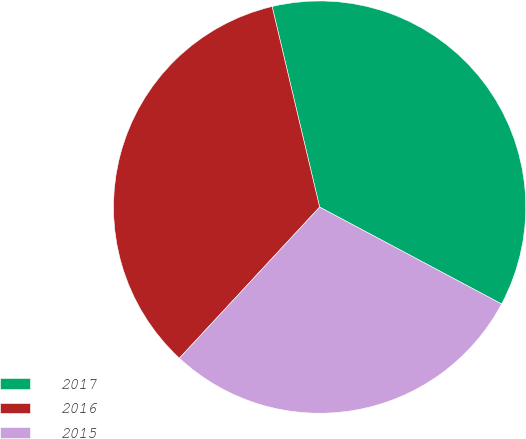Convert chart. <chart><loc_0><loc_0><loc_500><loc_500><pie_chart><fcel>2017<fcel>2016<fcel>2015<nl><fcel>36.49%<fcel>34.39%<fcel>29.12%<nl></chart> 